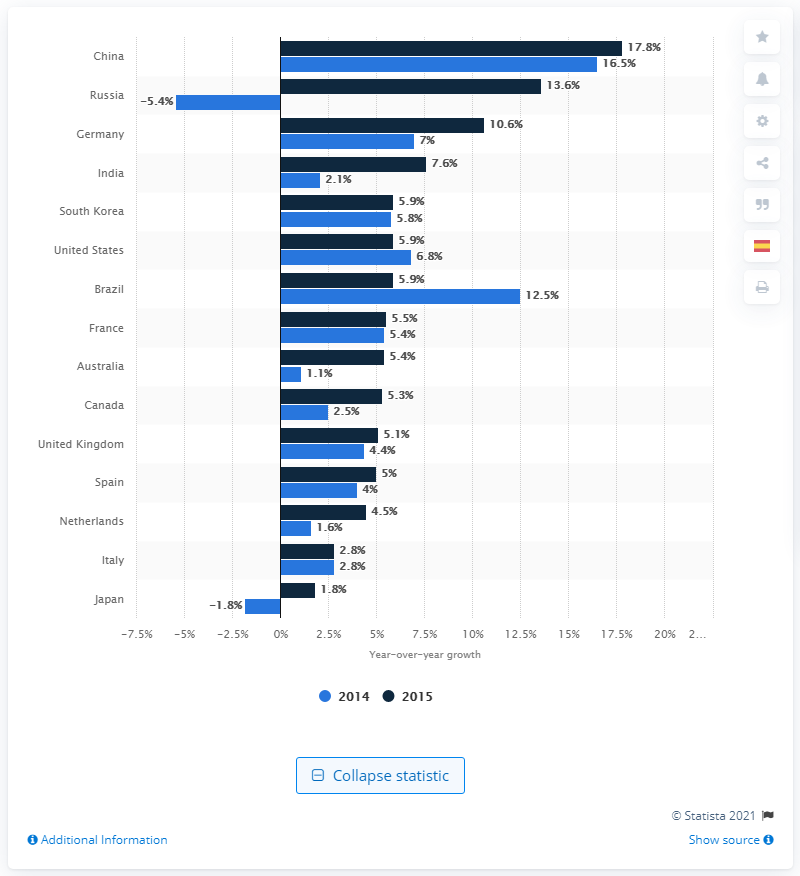Give some essential details in this illustration. The forecast decline in business travel spending in Russia in 2014 was expected to be 5.4%. 